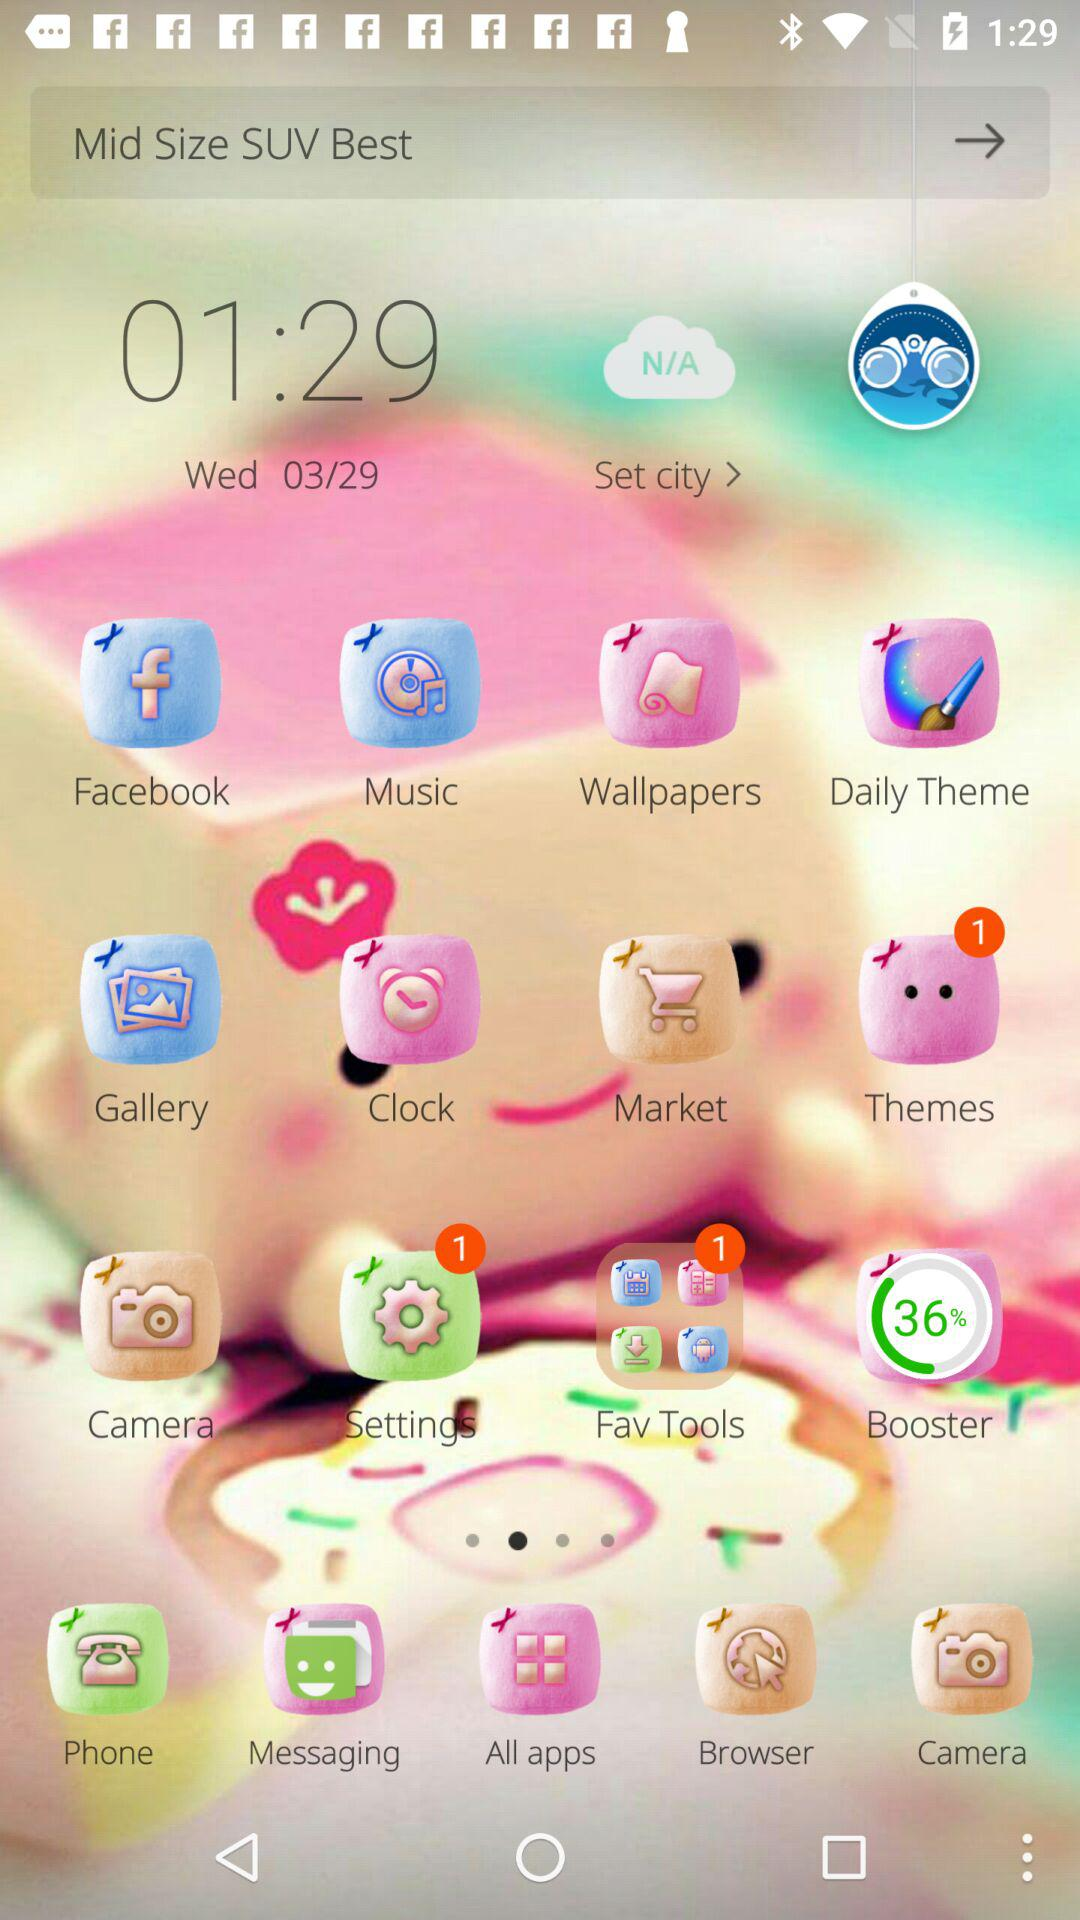What is the day given? The given day is Wednesday. 